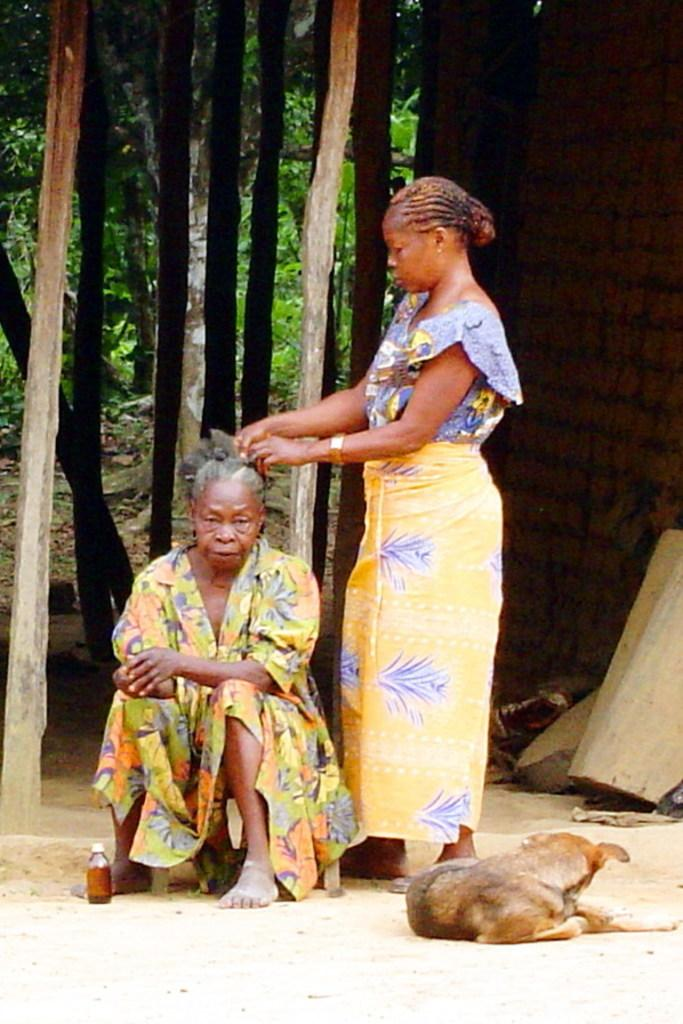How many people are in the foreground of the image? There are two women in the foreground of the image. What object is also present in the foreground of the image? There is a bottle in the foreground of the image. What animal is sitting in the foreground of the image? A dog is sitting on the road in the foreground of the image. What type of vegetation can be seen in the background of the image? Bamboo sticks are visible in the background of the image. What type of structure is visible in the background of the image? There is a wall in the background of the image. What else can be seen in the background of the image? Trees are present in the background of the image. What time of day was the image taken? The image was taken during the day. What type of credit card is being used by one of the women in the image? There is no credit card visible in the image. 